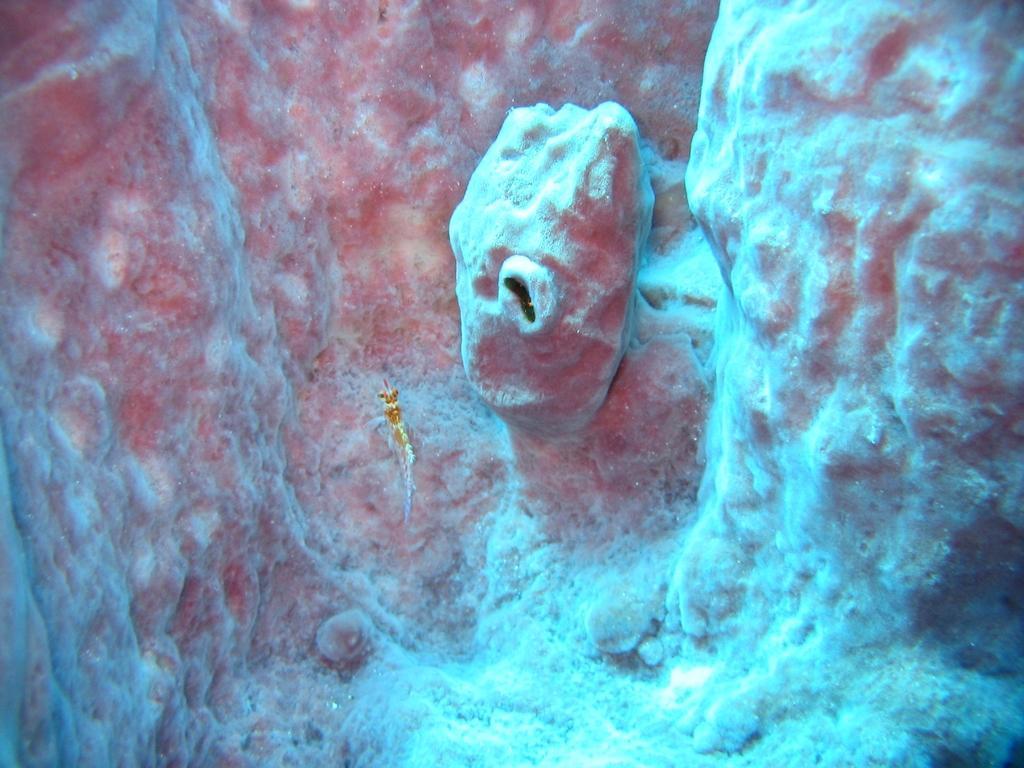Describe this image in one or two sentences. In the image we can see there is a fish in the water and there are small hills. 